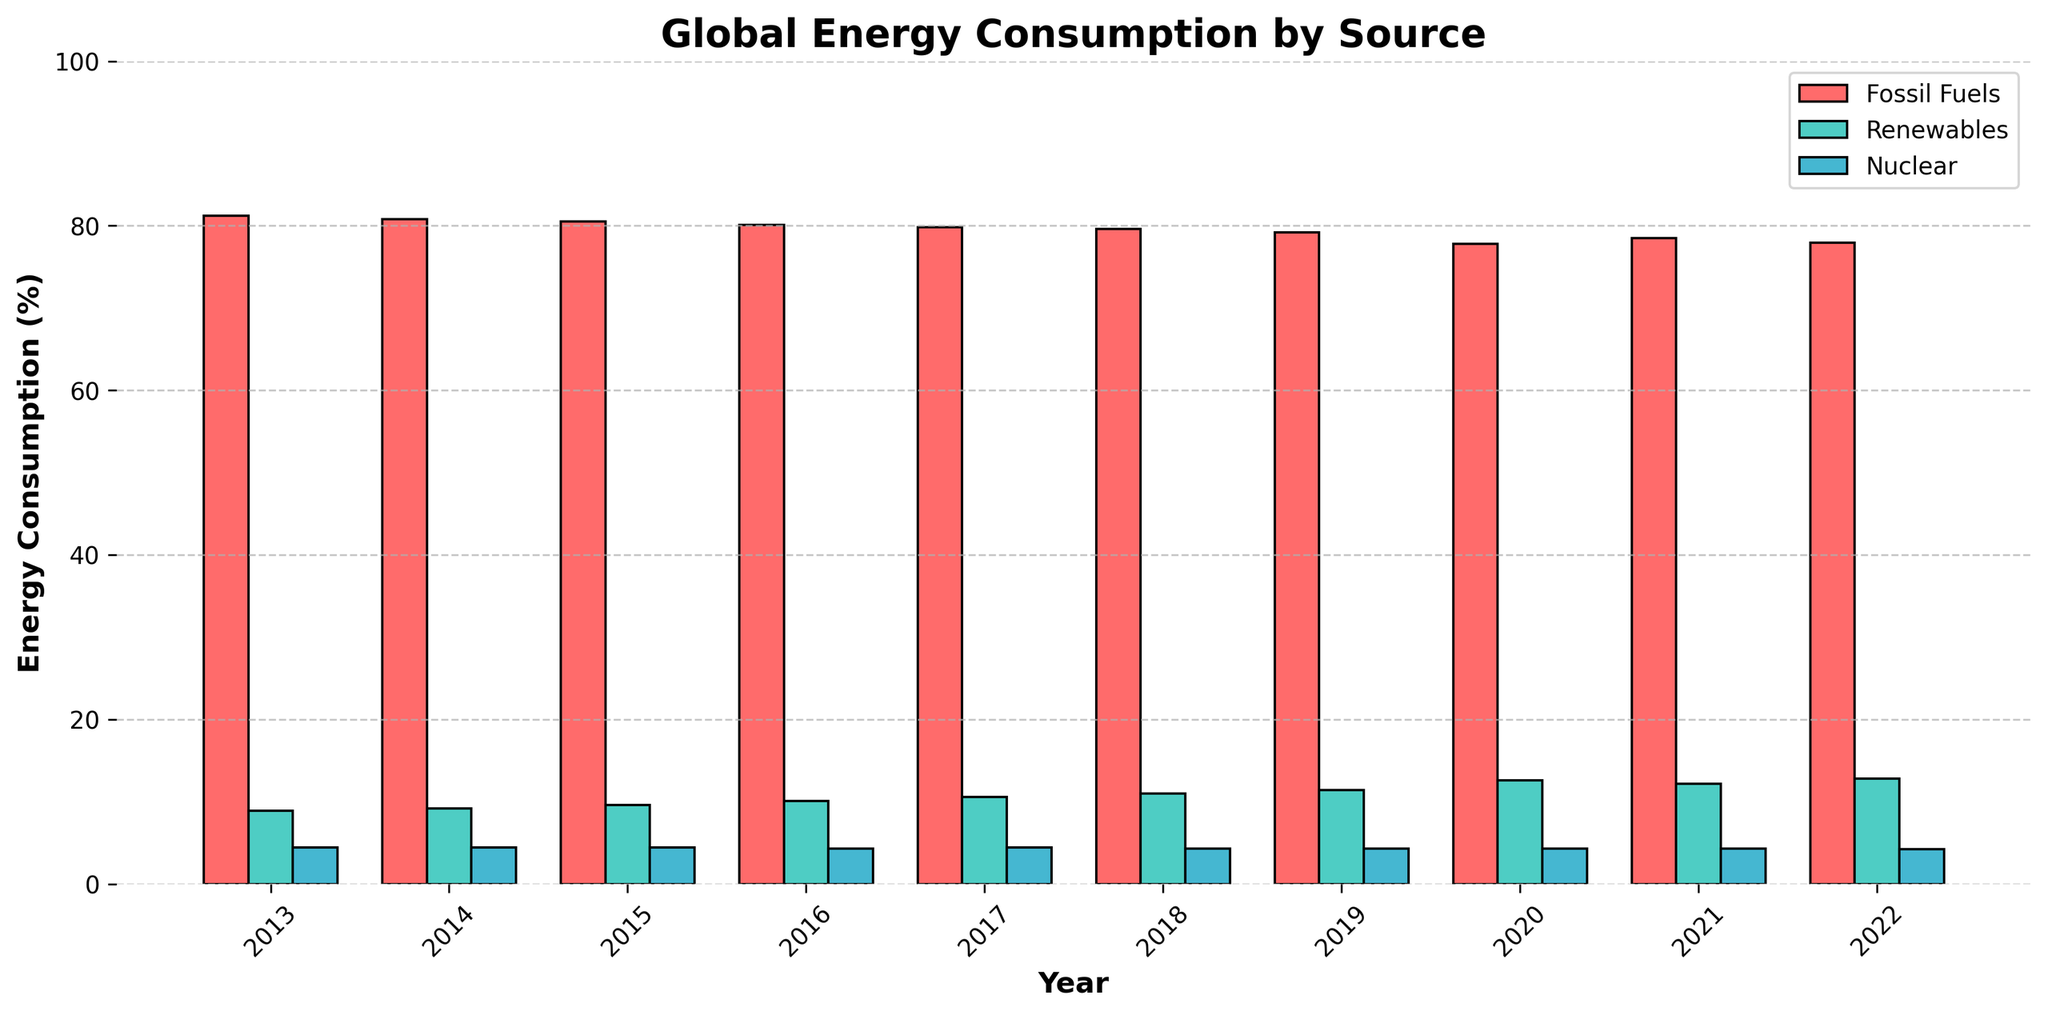What is the general trend of renewable energy consumption from 2013 to 2022? Observe the green bars in the chart that represent renewable energy consumption. Starting from 8.9% in 2013, the height of these bars consistently increases each year, reaching 12.8% in 2022. This indicates an increasing trend in renewable energy consumption over the decade.
Answer: Increasing Which year had the highest consumption of fossil fuels? Look at the red bars in the graph. The tallest red bar corresponds to the year 2013, with a fossil fuel consumption of 81.2%.
Answer: 2013 In 2020, compare the consumption of fossil fuels and renewables. Which was higher and by how much? Find the heights of the bars for 2020 for both fossil fuels and renewables. The fossil fuel consumption is 77.8%, and renewables is 12.6%. Subtract the renewables' percentage from fossil fuels' percentage (77.8% - 12.6% = 65.2%). Fossil fuels were higher by 65.2%.
Answer: Fossil fuels by 65.2% What is the difference in fossil fuel consumption between 2013 and 2022? Look at the fossil fuel bars for 2013 and 2022. The heights are 81.2% (2013) and 77.9% (2022). Subtract the 2022 value from the 2013 value (81.2% - 77.9% = 3.3%).
Answer: 3.3% What is the average nuclear energy consumption over the period? Examine the blue bars for nuclear energy from 2013 to 2022. The values are 4.4, 4.4, 4.4, 4.3, 4.4, 4.3, 4.3, 4.3, 4.3, and 4.2. Sum these values (4.4 + 4.4 + 4.4 + 4.3 + 4.4 + 4.3 + 4.3 + 4.3 + 4.3 + 4.2 = 42.7). Then, divide by the number of years (42.7 / 10 = 4.27).
Answer: 4.27 By looking at the visual attributes, in which year did renewables surpass 10% of global energy consumption for the first time? Check the green bars for renewables. In 2016, the bar height surpasses the 10% mark for the first time.
Answer: 2016 How did the consumption of renewables change from 2019 to 2020? Compare the heights of the green bars for 2019 and 2020. In 2019, it was 11.4%, and in 2020, it increased to 12.6%. The change is an increase of 1.2% (12.6% - 11.4%).
Answer: Increased by 1.2% Compare the heights of the blue bars (nuclear energy) between 2013 and 2022. What can you say about the trend? Observe the blue bars representing nuclear energy consumption in 2013 and 2022 and note their heights. The 2013 bar is at 4.4%, and the 2022 bar is slightly lower at 4.2%. This indicates a slight decrease in nuclear energy consumption over the years.
Answer: Slightly decreasing 